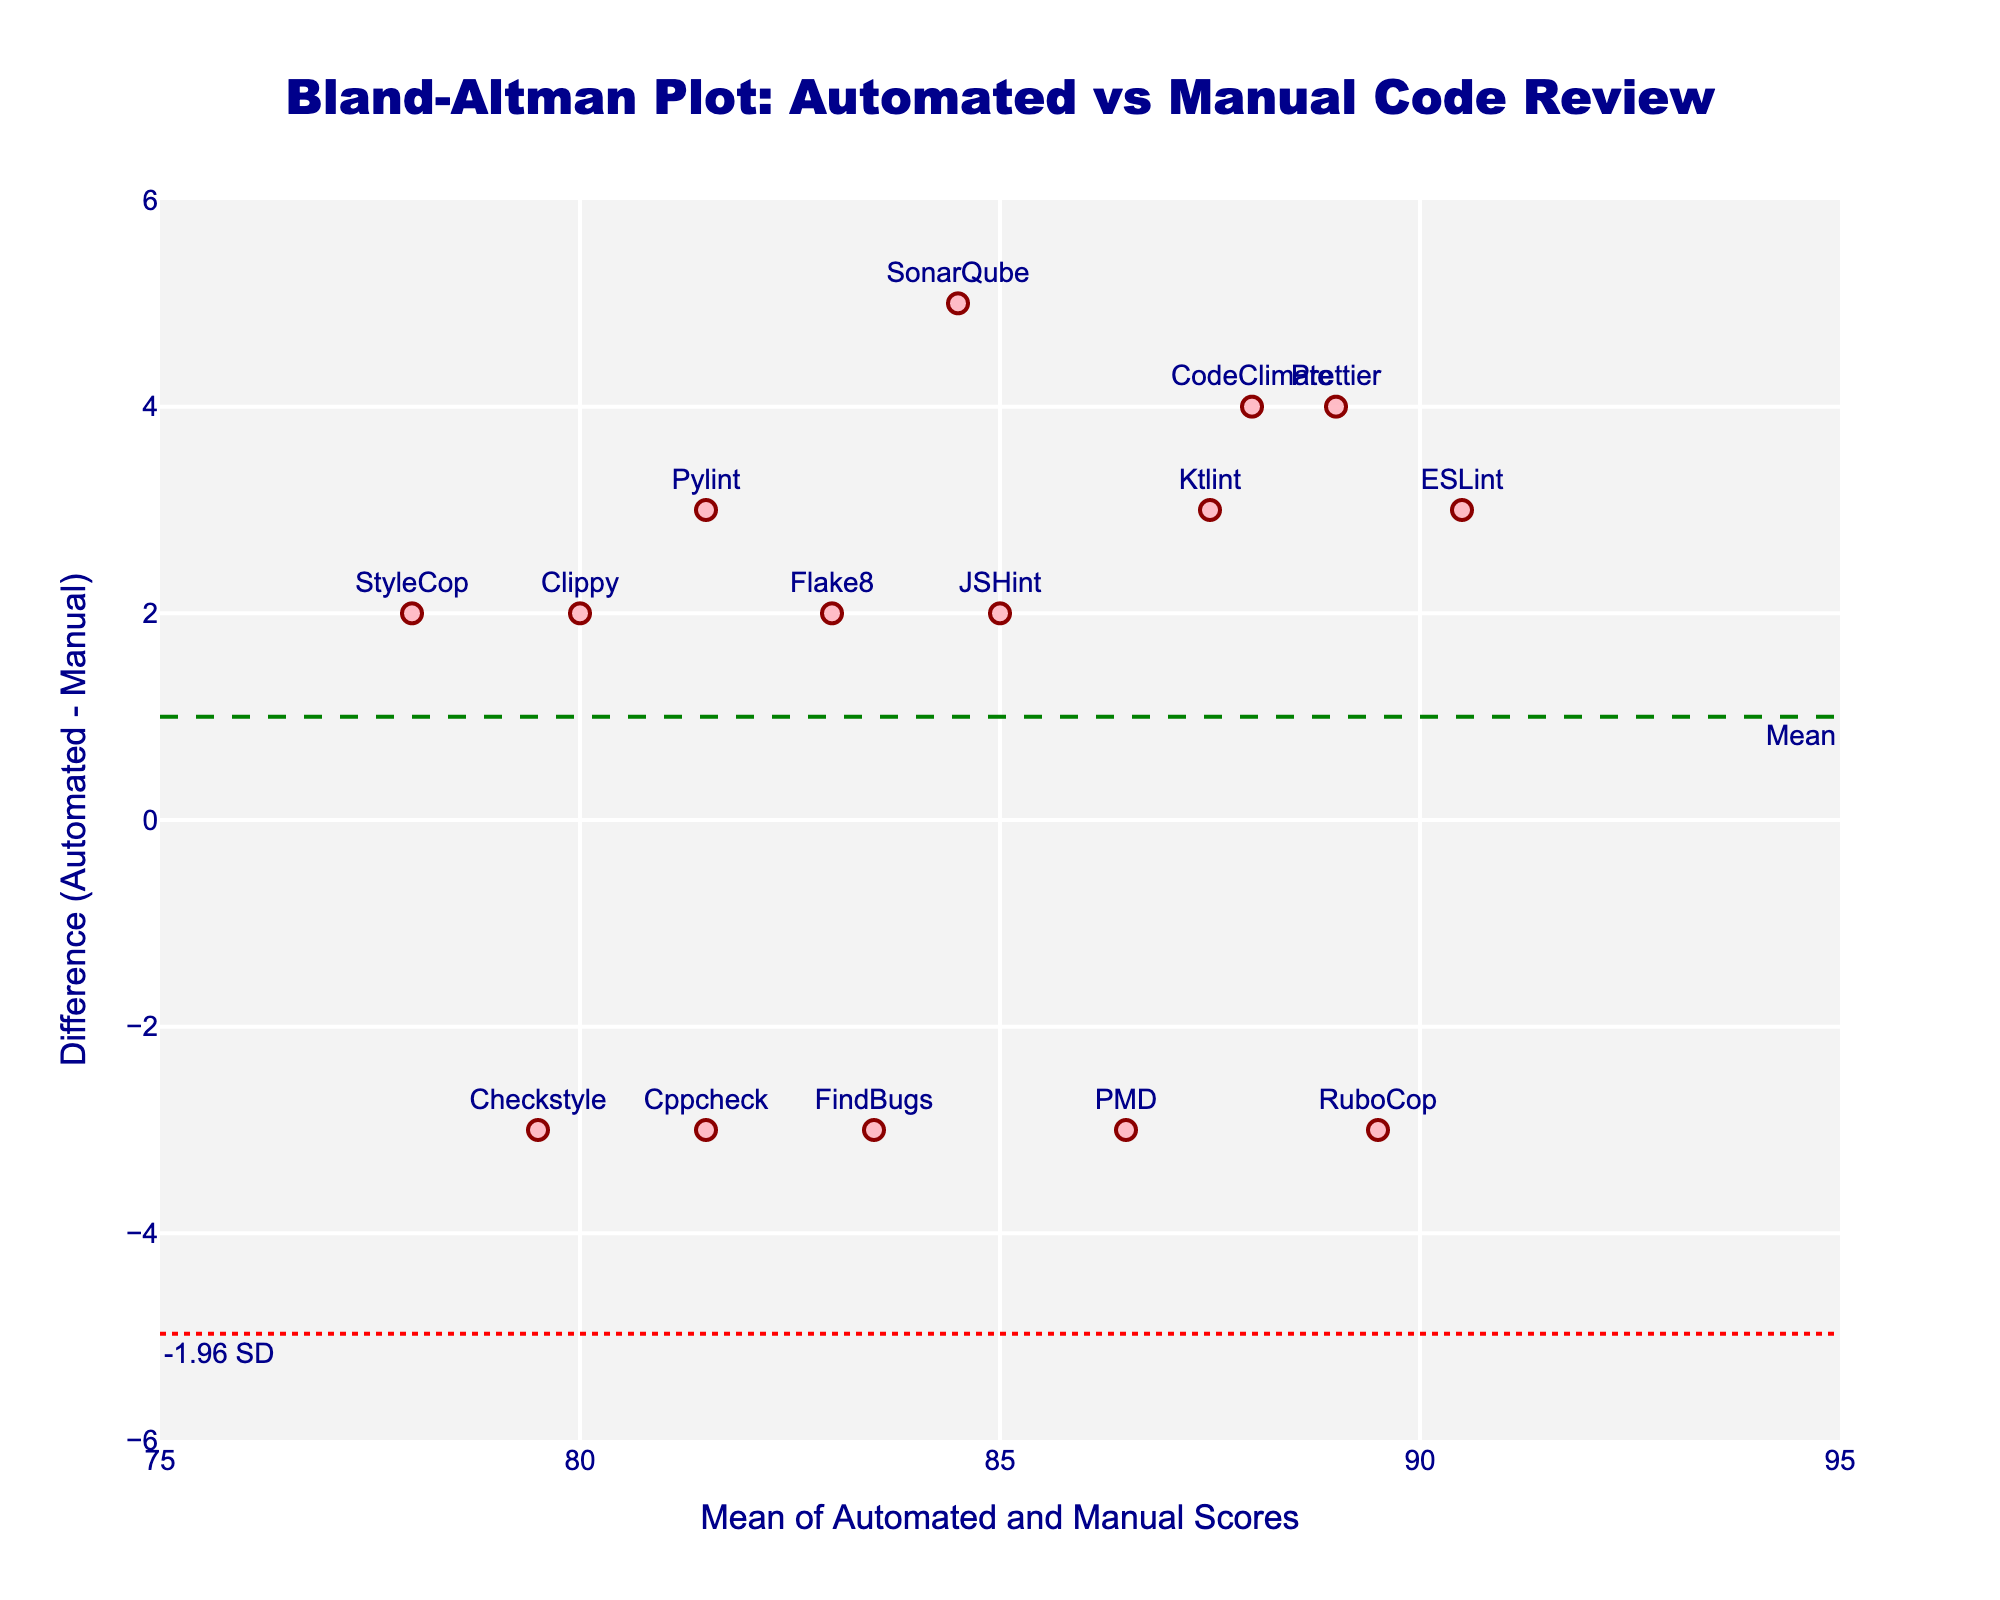what is the title of the figure? The title of the figure is typically located at the top of the plot, usually in larger and bolder font compared to other text elements. In this case, the title "Bland-Altman Plot: Automated vs Manual Code Review" is clearly visible at the top.
Answer: Bland-Altman Plot: Automated vs Manual Code Review What are the y-axis labels for the dotted red lines? The y-axis labels for the dotted red lines indicate the limits of agreement, usually found alongside the lines. In this figure, the labels are "-1.96 SD" and "+1.96 SD" located at the bottom left and top left respectively.
Answer: -1.96 SD, +1.96 SD What is the color of the data points? The color of the data points can be identified visually from the scatter plot. In this figure, the markers are colored pink, described specifically as 'rgba(255, 182, 193, 0.9)', with a dark red outline.
Answer: Pink Which code review tool shows the highest automated score? By observing the data points and their corresponding tool names, we can identify which tool is at the highest position on the x-axis for automated scores. "ESLint" has an automated score of 92, which is the highest among the tools listed.
Answer: ESLint How many data points fall within the limits of agreement? Limits of agreement lines are marked by dotted red lines. To find the number of data points within these lines, count the points between -1.96 and +1.96 on the y-axis. All the points lie within these limits.
Answer: All (15) What is the mean difference between automated and manual scores? The mean difference is represented by a dashed green line on the Bland-Altman plot, with a label "Mean." The location of this line on the y-axis gives the mean difference.
Answer: 0.067 Which tool has the largest positive difference between automated and manual scores? To identify this, observe the data points that are closest to the top on the y-axis, which shows the difference. "SonarQube" has the largest positive difference (87 - 82 = 5).
Answer: SonarQube What is the range of the x-axis? The range of the x-axis is from the minimum to the maximum value seen for "Mean of Automated and Manual Scores." By looking at the plot, the range is between approximately 75 and 95.
Answer: 75 to 95 What are the limits of agreement in numerical terms? The limits of agreement can be derived from the mean difference and standard deviation, given by ±1.96 * SD. From visual cues, the lines are dotted red ones on the plot. Looking at their positions on the y-axis, they are at approximately -1.93 and +2.07.
Answer: -1.93 to 2.07 